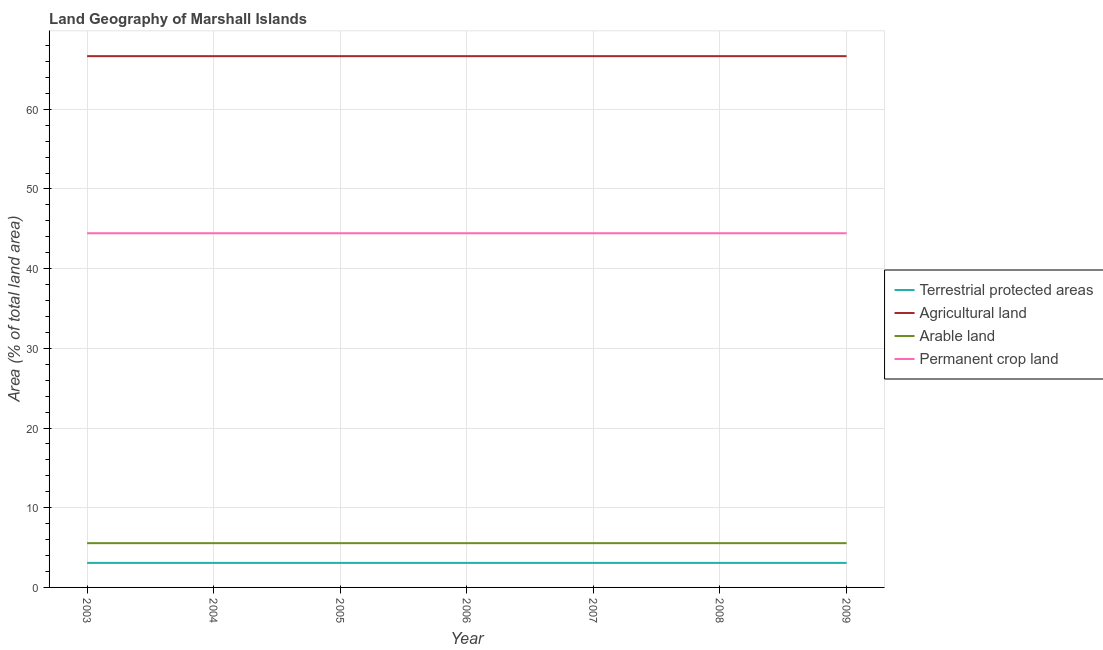How many different coloured lines are there?
Your answer should be compact. 4. Does the line corresponding to percentage of land under terrestrial protection intersect with the line corresponding to percentage of area under permanent crop land?
Your response must be concise. No. What is the percentage of area under agricultural land in 2008?
Offer a very short reply. 66.67. Across all years, what is the maximum percentage of area under arable land?
Offer a very short reply. 5.56. Across all years, what is the minimum percentage of land under terrestrial protection?
Provide a short and direct response. 3.08. In which year was the percentage of area under permanent crop land maximum?
Keep it short and to the point. 2003. In which year was the percentage of land under terrestrial protection minimum?
Give a very brief answer. 2003. What is the total percentage of area under arable land in the graph?
Your answer should be very brief. 38.89. What is the difference between the percentage of land under terrestrial protection in 2004 and that in 2008?
Offer a terse response. 0. What is the difference between the percentage of land under terrestrial protection in 2009 and the percentage of area under agricultural land in 2007?
Your answer should be very brief. -63.59. What is the average percentage of area under arable land per year?
Give a very brief answer. 5.56. In the year 2004, what is the difference between the percentage of area under agricultural land and percentage of land under terrestrial protection?
Provide a succinct answer. 63.59. Is it the case that in every year, the sum of the percentage of area under agricultural land and percentage of area under arable land is greater than the sum of percentage of area under permanent crop land and percentage of land under terrestrial protection?
Ensure brevity in your answer.  No. Does the percentage of area under permanent crop land monotonically increase over the years?
Give a very brief answer. No. How many years are there in the graph?
Your answer should be compact. 7. Where does the legend appear in the graph?
Make the answer very short. Center right. What is the title of the graph?
Provide a succinct answer. Land Geography of Marshall Islands. What is the label or title of the Y-axis?
Provide a short and direct response. Area (% of total land area). What is the Area (% of total land area) in Terrestrial protected areas in 2003?
Ensure brevity in your answer.  3.08. What is the Area (% of total land area) of Agricultural land in 2003?
Keep it short and to the point. 66.67. What is the Area (% of total land area) of Arable land in 2003?
Provide a succinct answer. 5.56. What is the Area (% of total land area) in Permanent crop land in 2003?
Your answer should be very brief. 44.44. What is the Area (% of total land area) in Terrestrial protected areas in 2004?
Your response must be concise. 3.08. What is the Area (% of total land area) of Agricultural land in 2004?
Ensure brevity in your answer.  66.67. What is the Area (% of total land area) of Arable land in 2004?
Your answer should be compact. 5.56. What is the Area (% of total land area) of Permanent crop land in 2004?
Offer a very short reply. 44.44. What is the Area (% of total land area) in Terrestrial protected areas in 2005?
Your response must be concise. 3.08. What is the Area (% of total land area) of Agricultural land in 2005?
Offer a terse response. 66.67. What is the Area (% of total land area) of Arable land in 2005?
Offer a very short reply. 5.56. What is the Area (% of total land area) of Permanent crop land in 2005?
Give a very brief answer. 44.44. What is the Area (% of total land area) of Terrestrial protected areas in 2006?
Offer a terse response. 3.08. What is the Area (% of total land area) of Agricultural land in 2006?
Your answer should be very brief. 66.67. What is the Area (% of total land area) of Arable land in 2006?
Your answer should be compact. 5.56. What is the Area (% of total land area) of Permanent crop land in 2006?
Provide a short and direct response. 44.44. What is the Area (% of total land area) in Terrestrial protected areas in 2007?
Make the answer very short. 3.08. What is the Area (% of total land area) in Agricultural land in 2007?
Provide a succinct answer. 66.67. What is the Area (% of total land area) in Arable land in 2007?
Offer a very short reply. 5.56. What is the Area (% of total land area) in Permanent crop land in 2007?
Offer a very short reply. 44.44. What is the Area (% of total land area) of Terrestrial protected areas in 2008?
Provide a short and direct response. 3.08. What is the Area (% of total land area) of Agricultural land in 2008?
Offer a very short reply. 66.67. What is the Area (% of total land area) of Arable land in 2008?
Keep it short and to the point. 5.56. What is the Area (% of total land area) in Permanent crop land in 2008?
Your response must be concise. 44.44. What is the Area (% of total land area) in Terrestrial protected areas in 2009?
Provide a succinct answer. 3.08. What is the Area (% of total land area) of Agricultural land in 2009?
Keep it short and to the point. 66.67. What is the Area (% of total land area) of Arable land in 2009?
Make the answer very short. 5.56. What is the Area (% of total land area) of Permanent crop land in 2009?
Your answer should be very brief. 44.44. Across all years, what is the maximum Area (% of total land area) of Terrestrial protected areas?
Ensure brevity in your answer.  3.08. Across all years, what is the maximum Area (% of total land area) of Agricultural land?
Give a very brief answer. 66.67. Across all years, what is the maximum Area (% of total land area) in Arable land?
Give a very brief answer. 5.56. Across all years, what is the maximum Area (% of total land area) of Permanent crop land?
Ensure brevity in your answer.  44.44. Across all years, what is the minimum Area (% of total land area) in Terrestrial protected areas?
Offer a terse response. 3.08. Across all years, what is the minimum Area (% of total land area) of Agricultural land?
Your answer should be very brief. 66.67. Across all years, what is the minimum Area (% of total land area) in Arable land?
Give a very brief answer. 5.56. Across all years, what is the minimum Area (% of total land area) in Permanent crop land?
Provide a short and direct response. 44.44. What is the total Area (% of total land area) in Terrestrial protected areas in the graph?
Offer a terse response. 21.55. What is the total Area (% of total land area) in Agricultural land in the graph?
Provide a short and direct response. 466.67. What is the total Area (% of total land area) of Arable land in the graph?
Make the answer very short. 38.89. What is the total Area (% of total land area) in Permanent crop land in the graph?
Offer a terse response. 311.11. What is the difference between the Area (% of total land area) in Terrestrial protected areas in 2003 and that in 2004?
Provide a succinct answer. 0. What is the difference between the Area (% of total land area) in Agricultural land in 2003 and that in 2004?
Your answer should be very brief. 0. What is the difference between the Area (% of total land area) of Arable land in 2003 and that in 2004?
Offer a terse response. 0. What is the difference between the Area (% of total land area) in Terrestrial protected areas in 2003 and that in 2006?
Make the answer very short. 0. What is the difference between the Area (% of total land area) in Terrestrial protected areas in 2003 and that in 2007?
Your response must be concise. 0. What is the difference between the Area (% of total land area) in Arable land in 2003 and that in 2007?
Your response must be concise. 0. What is the difference between the Area (% of total land area) in Permanent crop land in 2003 and that in 2007?
Provide a short and direct response. 0. What is the difference between the Area (% of total land area) in Agricultural land in 2003 and that in 2008?
Your answer should be very brief. 0. What is the difference between the Area (% of total land area) in Arable land in 2003 and that in 2008?
Offer a very short reply. 0. What is the difference between the Area (% of total land area) in Agricultural land in 2003 and that in 2009?
Provide a short and direct response. 0. What is the difference between the Area (% of total land area) in Arable land in 2003 and that in 2009?
Offer a very short reply. 0. What is the difference between the Area (% of total land area) in Terrestrial protected areas in 2004 and that in 2005?
Offer a very short reply. 0. What is the difference between the Area (% of total land area) of Arable land in 2004 and that in 2006?
Your answer should be compact. 0. What is the difference between the Area (% of total land area) in Arable land in 2004 and that in 2007?
Ensure brevity in your answer.  0. What is the difference between the Area (% of total land area) in Terrestrial protected areas in 2004 and that in 2009?
Make the answer very short. 0. What is the difference between the Area (% of total land area) of Agricultural land in 2004 and that in 2009?
Provide a short and direct response. 0. What is the difference between the Area (% of total land area) of Arable land in 2004 and that in 2009?
Your answer should be compact. 0. What is the difference between the Area (% of total land area) of Agricultural land in 2005 and that in 2006?
Keep it short and to the point. 0. What is the difference between the Area (% of total land area) in Permanent crop land in 2005 and that in 2006?
Provide a succinct answer. 0. What is the difference between the Area (% of total land area) in Terrestrial protected areas in 2005 and that in 2007?
Keep it short and to the point. 0. What is the difference between the Area (% of total land area) of Permanent crop land in 2005 and that in 2007?
Your answer should be very brief. 0. What is the difference between the Area (% of total land area) of Terrestrial protected areas in 2005 and that in 2008?
Keep it short and to the point. 0. What is the difference between the Area (% of total land area) in Agricultural land in 2005 and that in 2008?
Make the answer very short. 0. What is the difference between the Area (% of total land area) in Arable land in 2005 and that in 2008?
Your answer should be compact. 0. What is the difference between the Area (% of total land area) in Terrestrial protected areas in 2005 and that in 2009?
Give a very brief answer. 0. What is the difference between the Area (% of total land area) of Arable land in 2005 and that in 2009?
Your answer should be very brief. 0. What is the difference between the Area (% of total land area) in Terrestrial protected areas in 2006 and that in 2007?
Provide a short and direct response. 0. What is the difference between the Area (% of total land area) of Agricultural land in 2006 and that in 2007?
Your answer should be very brief. 0. What is the difference between the Area (% of total land area) in Arable land in 2006 and that in 2007?
Offer a very short reply. 0. What is the difference between the Area (% of total land area) in Permanent crop land in 2006 and that in 2008?
Provide a succinct answer. 0. What is the difference between the Area (% of total land area) in Arable land in 2006 and that in 2009?
Provide a short and direct response. 0. What is the difference between the Area (% of total land area) of Permanent crop land in 2006 and that in 2009?
Offer a very short reply. 0. What is the difference between the Area (% of total land area) in Terrestrial protected areas in 2007 and that in 2008?
Your answer should be compact. 0. What is the difference between the Area (% of total land area) in Agricultural land in 2007 and that in 2008?
Ensure brevity in your answer.  0. What is the difference between the Area (% of total land area) of Permanent crop land in 2007 and that in 2008?
Give a very brief answer. 0. What is the difference between the Area (% of total land area) in Arable land in 2007 and that in 2009?
Your answer should be compact. 0. What is the difference between the Area (% of total land area) in Permanent crop land in 2007 and that in 2009?
Your response must be concise. 0. What is the difference between the Area (% of total land area) of Agricultural land in 2008 and that in 2009?
Ensure brevity in your answer.  0. What is the difference between the Area (% of total land area) of Permanent crop land in 2008 and that in 2009?
Offer a very short reply. 0. What is the difference between the Area (% of total land area) in Terrestrial protected areas in 2003 and the Area (% of total land area) in Agricultural land in 2004?
Offer a very short reply. -63.59. What is the difference between the Area (% of total land area) in Terrestrial protected areas in 2003 and the Area (% of total land area) in Arable land in 2004?
Your answer should be compact. -2.48. What is the difference between the Area (% of total land area) of Terrestrial protected areas in 2003 and the Area (% of total land area) of Permanent crop land in 2004?
Make the answer very short. -41.37. What is the difference between the Area (% of total land area) of Agricultural land in 2003 and the Area (% of total land area) of Arable land in 2004?
Ensure brevity in your answer.  61.11. What is the difference between the Area (% of total land area) in Agricultural land in 2003 and the Area (% of total land area) in Permanent crop land in 2004?
Your answer should be very brief. 22.22. What is the difference between the Area (% of total land area) in Arable land in 2003 and the Area (% of total land area) in Permanent crop land in 2004?
Provide a succinct answer. -38.89. What is the difference between the Area (% of total land area) of Terrestrial protected areas in 2003 and the Area (% of total land area) of Agricultural land in 2005?
Provide a succinct answer. -63.59. What is the difference between the Area (% of total land area) in Terrestrial protected areas in 2003 and the Area (% of total land area) in Arable land in 2005?
Give a very brief answer. -2.48. What is the difference between the Area (% of total land area) in Terrestrial protected areas in 2003 and the Area (% of total land area) in Permanent crop land in 2005?
Keep it short and to the point. -41.37. What is the difference between the Area (% of total land area) of Agricultural land in 2003 and the Area (% of total land area) of Arable land in 2005?
Your answer should be very brief. 61.11. What is the difference between the Area (% of total land area) in Agricultural land in 2003 and the Area (% of total land area) in Permanent crop land in 2005?
Offer a very short reply. 22.22. What is the difference between the Area (% of total land area) of Arable land in 2003 and the Area (% of total land area) of Permanent crop land in 2005?
Your answer should be compact. -38.89. What is the difference between the Area (% of total land area) of Terrestrial protected areas in 2003 and the Area (% of total land area) of Agricultural land in 2006?
Your answer should be compact. -63.59. What is the difference between the Area (% of total land area) of Terrestrial protected areas in 2003 and the Area (% of total land area) of Arable land in 2006?
Ensure brevity in your answer.  -2.48. What is the difference between the Area (% of total land area) of Terrestrial protected areas in 2003 and the Area (% of total land area) of Permanent crop land in 2006?
Offer a terse response. -41.37. What is the difference between the Area (% of total land area) in Agricultural land in 2003 and the Area (% of total land area) in Arable land in 2006?
Give a very brief answer. 61.11. What is the difference between the Area (% of total land area) in Agricultural land in 2003 and the Area (% of total land area) in Permanent crop land in 2006?
Offer a terse response. 22.22. What is the difference between the Area (% of total land area) of Arable land in 2003 and the Area (% of total land area) of Permanent crop land in 2006?
Provide a succinct answer. -38.89. What is the difference between the Area (% of total land area) in Terrestrial protected areas in 2003 and the Area (% of total land area) in Agricultural land in 2007?
Make the answer very short. -63.59. What is the difference between the Area (% of total land area) of Terrestrial protected areas in 2003 and the Area (% of total land area) of Arable land in 2007?
Provide a short and direct response. -2.48. What is the difference between the Area (% of total land area) in Terrestrial protected areas in 2003 and the Area (% of total land area) in Permanent crop land in 2007?
Offer a terse response. -41.37. What is the difference between the Area (% of total land area) of Agricultural land in 2003 and the Area (% of total land area) of Arable land in 2007?
Provide a short and direct response. 61.11. What is the difference between the Area (% of total land area) of Agricultural land in 2003 and the Area (% of total land area) of Permanent crop land in 2007?
Provide a short and direct response. 22.22. What is the difference between the Area (% of total land area) in Arable land in 2003 and the Area (% of total land area) in Permanent crop land in 2007?
Keep it short and to the point. -38.89. What is the difference between the Area (% of total land area) of Terrestrial protected areas in 2003 and the Area (% of total land area) of Agricultural land in 2008?
Your answer should be compact. -63.59. What is the difference between the Area (% of total land area) of Terrestrial protected areas in 2003 and the Area (% of total land area) of Arable land in 2008?
Give a very brief answer. -2.48. What is the difference between the Area (% of total land area) of Terrestrial protected areas in 2003 and the Area (% of total land area) of Permanent crop land in 2008?
Offer a terse response. -41.37. What is the difference between the Area (% of total land area) of Agricultural land in 2003 and the Area (% of total land area) of Arable land in 2008?
Provide a succinct answer. 61.11. What is the difference between the Area (% of total land area) of Agricultural land in 2003 and the Area (% of total land area) of Permanent crop land in 2008?
Offer a very short reply. 22.22. What is the difference between the Area (% of total land area) in Arable land in 2003 and the Area (% of total land area) in Permanent crop land in 2008?
Your answer should be compact. -38.89. What is the difference between the Area (% of total land area) of Terrestrial protected areas in 2003 and the Area (% of total land area) of Agricultural land in 2009?
Offer a terse response. -63.59. What is the difference between the Area (% of total land area) of Terrestrial protected areas in 2003 and the Area (% of total land area) of Arable land in 2009?
Keep it short and to the point. -2.48. What is the difference between the Area (% of total land area) of Terrestrial protected areas in 2003 and the Area (% of total land area) of Permanent crop land in 2009?
Make the answer very short. -41.37. What is the difference between the Area (% of total land area) of Agricultural land in 2003 and the Area (% of total land area) of Arable land in 2009?
Ensure brevity in your answer.  61.11. What is the difference between the Area (% of total land area) in Agricultural land in 2003 and the Area (% of total land area) in Permanent crop land in 2009?
Offer a very short reply. 22.22. What is the difference between the Area (% of total land area) in Arable land in 2003 and the Area (% of total land area) in Permanent crop land in 2009?
Your response must be concise. -38.89. What is the difference between the Area (% of total land area) of Terrestrial protected areas in 2004 and the Area (% of total land area) of Agricultural land in 2005?
Offer a very short reply. -63.59. What is the difference between the Area (% of total land area) of Terrestrial protected areas in 2004 and the Area (% of total land area) of Arable land in 2005?
Your response must be concise. -2.48. What is the difference between the Area (% of total land area) of Terrestrial protected areas in 2004 and the Area (% of total land area) of Permanent crop land in 2005?
Your answer should be compact. -41.37. What is the difference between the Area (% of total land area) of Agricultural land in 2004 and the Area (% of total land area) of Arable land in 2005?
Keep it short and to the point. 61.11. What is the difference between the Area (% of total land area) in Agricultural land in 2004 and the Area (% of total land area) in Permanent crop land in 2005?
Provide a short and direct response. 22.22. What is the difference between the Area (% of total land area) in Arable land in 2004 and the Area (% of total land area) in Permanent crop land in 2005?
Provide a short and direct response. -38.89. What is the difference between the Area (% of total land area) in Terrestrial protected areas in 2004 and the Area (% of total land area) in Agricultural land in 2006?
Your answer should be very brief. -63.59. What is the difference between the Area (% of total land area) of Terrestrial protected areas in 2004 and the Area (% of total land area) of Arable land in 2006?
Your response must be concise. -2.48. What is the difference between the Area (% of total land area) of Terrestrial protected areas in 2004 and the Area (% of total land area) of Permanent crop land in 2006?
Your answer should be compact. -41.37. What is the difference between the Area (% of total land area) of Agricultural land in 2004 and the Area (% of total land area) of Arable land in 2006?
Your answer should be very brief. 61.11. What is the difference between the Area (% of total land area) of Agricultural land in 2004 and the Area (% of total land area) of Permanent crop land in 2006?
Offer a terse response. 22.22. What is the difference between the Area (% of total land area) of Arable land in 2004 and the Area (% of total land area) of Permanent crop land in 2006?
Make the answer very short. -38.89. What is the difference between the Area (% of total land area) in Terrestrial protected areas in 2004 and the Area (% of total land area) in Agricultural land in 2007?
Offer a very short reply. -63.59. What is the difference between the Area (% of total land area) of Terrestrial protected areas in 2004 and the Area (% of total land area) of Arable land in 2007?
Offer a very short reply. -2.48. What is the difference between the Area (% of total land area) of Terrestrial protected areas in 2004 and the Area (% of total land area) of Permanent crop land in 2007?
Offer a very short reply. -41.37. What is the difference between the Area (% of total land area) in Agricultural land in 2004 and the Area (% of total land area) in Arable land in 2007?
Provide a short and direct response. 61.11. What is the difference between the Area (% of total land area) in Agricultural land in 2004 and the Area (% of total land area) in Permanent crop land in 2007?
Give a very brief answer. 22.22. What is the difference between the Area (% of total land area) of Arable land in 2004 and the Area (% of total land area) of Permanent crop land in 2007?
Offer a terse response. -38.89. What is the difference between the Area (% of total land area) in Terrestrial protected areas in 2004 and the Area (% of total land area) in Agricultural land in 2008?
Keep it short and to the point. -63.59. What is the difference between the Area (% of total land area) in Terrestrial protected areas in 2004 and the Area (% of total land area) in Arable land in 2008?
Keep it short and to the point. -2.48. What is the difference between the Area (% of total land area) of Terrestrial protected areas in 2004 and the Area (% of total land area) of Permanent crop land in 2008?
Your answer should be very brief. -41.37. What is the difference between the Area (% of total land area) of Agricultural land in 2004 and the Area (% of total land area) of Arable land in 2008?
Your answer should be very brief. 61.11. What is the difference between the Area (% of total land area) in Agricultural land in 2004 and the Area (% of total land area) in Permanent crop land in 2008?
Offer a terse response. 22.22. What is the difference between the Area (% of total land area) of Arable land in 2004 and the Area (% of total land area) of Permanent crop land in 2008?
Give a very brief answer. -38.89. What is the difference between the Area (% of total land area) in Terrestrial protected areas in 2004 and the Area (% of total land area) in Agricultural land in 2009?
Provide a succinct answer. -63.59. What is the difference between the Area (% of total land area) of Terrestrial protected areas in 2004 and the Area (% of total land area) of Arable land in 2009?
Your response must be concise. -2.48. What is the difference between the Area (% of total land area) of Terrestrial protected areas in 2004 and the Area (% of total land area) of Permanent crop land in 2009?
Your answer should be compact. -41.37. What is the difference between the Area (% of total land area) of Agricultural land in 2004 and the Area (% of total land area) of Arable land in 2009?
Your answer should be compact. 61.11. What is the difference between the Area (% of total land area) in Agricultural land in 2004 and the Area (% of total land area) in Permanent crop land in 2009?
Your answer should be very brief. 22.22. What is the difference between the Area (% of total land area) in Arable land in 2004 and the Area (% of total land area) in Permanent crop land in 2009?
Keep it short and to the point. -38.89. What is the difference between the Area (% of total land area) in Terrestrial protected areas in 2005 and the Area (% of total land area) in Agricultural land in 2006?
Your answer should be compact. -63.59. What is the difference between the Area (% of total land area) of Terrestrial protected areas in 2005 and the Area (% of total land area) of Arable land in 2006?
Your response must be concise. -2.48. What is the difference between the Area (% of total land area) in Terrestrial protected areas in 2005 and the Area (% of total land area) in Permanent crop land in 2006?
Make the answer very short. -41.37. What is the difference between the Area (% of total land area) of Agricultural land in 2005 and the Area (% of total land area) of Arable land in 2006?
Give a very brief answer. 61.11. What is the difference between the Area (% of total land area) of Agricultural land in 2005 and the Area (% of total land area) of Permanent crop land in 2006?
Offer a terse response. 22.22. What is the difference between the Area (% of total land area) of Arable land in 2005 and the Area (% of total land area) of Permanent crop land in 2006?
Offer a very short reply. -38.89. What is the difference between the Area (% of total land area) of Terrestrial protected areas in 2005 and the Area (% of total land area) of Agricultural land in 2007?
Provide a short and direct response. -63.59. What is the difference between the Area (% of total land area) of Terrestrial protected areas in 2005 and the Area (% of total land area) of Arable land in 2007?
Your answer should be very brief. -2.48. What is the difference between the Area (% of total land area) of Terrestrial protected areas in 2005 and the Area (% of total land area) of Permanent crop land in 2007?
Provide a succinct answer. -41.37. What is the difference between the Area (% of total land area) in Agricultural land in 2005 and the Area (% of total land area) in Arable land in 2007?
Ensure brevity in your answer.  61.11. What is the difference between the Area (% of total land area) in Agricultural land in 2005 and the Area (% of total land area) in Permanent crop land in 2007?
Ensure brevity in your answer.  22.22. What is the difference between the Area (% of total land area) in Arable land in 2005 and the Area (% of total land area) in Permanent crop land in 2007?
Keep it short and to the point. -38.89. What is the difference between the Area (% of total land area) in Terrestrial protected areas in 2005 and the Area (% of total land area) in Agricultural land in 2008?
Keep it short and to the point. -63.59. What is the difference between the Area (% of total land area) in Terrestrial protected areas in 2005 and the Area (% of total land area) in Arable land in 2008?
Provide a succinct answer. -2.48. What is the difference between the Area (% of total land area) in Terrestrial protected areas in 2005 and the Area (% of total land area) in Permanent crop land in 2008?
Provide a succinct answer. -41.37. What is the difference between the Area (% of total land area) of Agricultural land in 2005 and the Area (% of total land area) of Arable land in 2008?
Your answer should be compact. 61.11. What is the difference between the Area (% of total land area) of Agricultural land in 2005 and the Area (% of total land area) of Permanent crop land in 2008?
Your response must be concise. 22.22. What is the difference between the Area (% of total land area) of Arable land in 2005 and the Area (% of total land area) of Permanent crop land in 2008?
Give a very brief answer. -38.89. What is the difference between the Area (% of total land area) of Terrestrial protected areas in 2005 and the Area (% of total land area) of Agricultural land in 2009?
Give a very brief answer. -63.59. What is the difference between the Area (% of total land area) of Terrestrial protected areas in 2005 and the Area (% of total land area) of Arable land in 2009?
Your response must be concise. -2.48. What is the difference between the Area (% of total land area) in Terrestrial protected areas in 2005 and the Area (% of total land area) in Permanent crop land in 2009?
Keep it short and to the point. -41.37. What is the difference between the Area (% of total land area) of Agricultural land in 2005 and the Area (% of total land area) of Arable land in 2009?
Offer a terse response. 61.11. What is the difference between the Area (% of total land area) of Agricultural land in 2005 and the Area (% of total land area) of Permanent crop land in 2009?
Keep it short and to the point. 22.22. What is the difference between the Area (% of total land area) of Arable land in 2005 and the Area (% of total land area) of Permanent crop land in 2009?
Provide a succinct answer. -38.89. What is the difference between the Area (% of total land area) of Terrestrial protected areas in 2006 and the Area (% of total land area) of Agricultural land in 2007?
Provide a succinct answer. -63.59. What is the difference between the Area (% of total land area) of Terrestrial protected areas in 2006 and the Area (% of total land area) of Arable land in 2007?
Provide a short and direct response. -2.48. What is the difference between the Area (% of total land area) of Terrestrial protected areas in 2006 and the Area (% of total land area) of Permanent crop land in 2007?
Make the answer very short. -41.37. What is the difference between the Area (% of total land area) in Agricultural land in 2006 and the Area (% of total land area) in Arable land in 2007?
Offer a terse response. 61.11. What is the difference between the Area (% of total land area) in Agricultural land in 2006 and the Area (% of total land area) in Permanent crop land in 2007?
Ensure brevity in your answer.  22.22. What is the difference between the Area (% of total land area) in Arable land in 2006 and the Area (% of total land area) in Permanent crop land in 2007?
Your answer should be very brief. -38.89. What is the difference between the Area (% of total land area) in Terrestrial protected areas in 2006 and the Area (% of total land area) in Agricultural land in 2008?
Ensure brevity in your answer.  -63.59. What is the difference between the Area (% of total land area) of Terrestrial protected areas in 2006 and the Area (% of total land area) of Arable land in 2008?
Offer a very short reply. -2.48. What is the difference between the Area (% of total land area) of Terrestrial protected areas in 2006 and the Area (% of total land area) of Permanent crop land in 2008?
Provide a succinct answer. -41.37. What is the difference between the Area (% of total land area) of Agricultural land in 2006 and the Area (% of total land area) of Arable land in 2008?
Offer a very short reply. 61.11. What is the difference between the Area (% of total land area) of Agricultural land in 2006 and the Area (% of total land area) of Permanent crop land in 2008?
Keep it short and to the point. 22.22. What is the difference between the Area (% of total land area) of Arable land in 2006 and the Area (% of total land area) of Permanent crop land in 2008?
Your response must be concise. -38.89. What is the difference between the Area (% of total land area) in Terrestrial protected areas in 2006 and the Area (% of total land area) in Agricultural land in 2009?
Provide a succinct answer. -63.59. What is the difference between the Area (% of total land area) of Terrestrial protected areas in 2006 and the Area (% of total land area) of Arable land in 2009?
Provide a succinct answer. -2.48. What is the difference between the Area (% of total land area) in Terrestrial protected areas in 2006 and the Area (% of total land area) in Permanent crop land in 2009?
Provide a succinct answer. -41.37. What is the difference between the Area (% of total land area) in Agricultural land in 2006 and the Area (% of total land area) in Arable land in 2009?
Make the answer very short. 61.11. What is the difference between the Area (% of total land area) of Agricultural land in 2006 and the Area (% of total land area) of Permanent crop land in 2009?
Give a very brief answer. 22.22. What is the difference between the Area (% of total land area) in Arable land in 2006 and the Area (% of total land area) in Permanent crop land in 2009?
Offer a very short reply. -38.89. What is the difference between the Area (% of total land area) of Terrestrial protected areas in 2007 and the Area (% of total land area) of Agricultural land in 2008?
Provide a short and direct response. -63.59. What is the difference between the Area (% of total land area) in Terrestrial protected areas in 2007 and the Area (% of total land area) in Arable land in 2008?
Offer a very short reply. -2.48. What is the difference between the Area (% of total land area) in Terrestrial protected areas in 2007 and the Area (% of total land area) in Permanent crop land in 2008?
Give a very brief answer. -41.37. What is the difference between the Area (% of total land area) of Agricultural land in 2007 and the Area (% of total land area) of Arable land in 2008?
Keep it short and to the point. 61.11. What is the difference between the Area (% of total land area) of Agricultural land in 2007 and the Area (% of total land area) of Permanent crop land in 2008?
Keep it short and to the point. 22.22. What is the difference between the Area (% of total land area) in Arable land in 2007 and the Area (% of total land area) in Permanent crop land in 2008?
Offer a terse response. -38.89. What is the difference between the Area (% of total land area) of Terrestrial protected areas in 2007 and the Area (% of total land area) of Agricultural land in 2009?
Provide a succinct answer. -63.59. What is the difference between the Area (% of total land area) of Terrestrial protected areas in 2007 and the Area (% of total land area) of Arable land in 2009?
Make the answer very short. -2.48. What is the difference between the Area (% of total land area) in Terrestrial protected areas in 2007 and the Area (% of total land area) in Permanent crop land in 2009?
Ensure brevity in your answer.  -41.37. What is the difference between the Area (% of total land area) of Agricultural land in 2007 and the Area (% of total land area) of Arable land in 2009?
Give a very brief answer. 61.11. What is the difference between the Area (% of total land area) in Agricultural land in 2007 and the Area (% of total land area) in Permanent crop land in 2009?
Your answer should be compact. 22.22. What is the difference between the Area (% of total land area) of Arable land in 2007 and the Area (% of total land area) of Permanent crop land in 2009?
Offer a very short reply. -38.89. What is the difference between the Area (% of total land area) in Terrestrial protected areas in 2008 and the Area (% of total land area) in Agricultural land in 2009?
Your answer should be compact. -63.59. What is the difference between the Area (% of total land area) of Terrestrial protected areas in 2008 and the Area (% of total land area) of Arable land in 2009?
Give a very brief answer. -2.48. What is the difference between the Area (% of total land area) in Terrestrial protected areas in 2008 and the Area (% of total land area) in Permanent crop land in 2009?
Ensure brevity in your answer.  -41.37. What is the difference between the Area (% of total land area) of Agricultural land in 2008 and the Area (% of total land area) of Arable land in 2009?
Offer a terse response. 61.11. What is the difference between the Area (% of total land area) of Agricultural land in 2008 and the Area (% of total land area) of Permanent crop land in 2009?
Give a very brief answer. 22.22. What is the difference between the Area (% of total land area) in Arable land in 2008 and the Area (% of total land area) in Permanent crop land in 2009?
Your response must be concise. -38.89. What is the average Area (% of total land area) of Terrestrial protected areas per year?
Your answer should be very brief. 3.08. What is the average Area (% of total land area) in Agricultural land per year?
Keep it short and to the point. 66.67. What is the average Area (% of total land area) of Arable land per year?
Keep it short and to the point. 5.56. What is the average Area (% of total land area) of Permanent crop land per year?
Give a very brief answer. 44.44. In the year 2003, what is the difference between the Area (% of total land area) in Terrestrial protected areas and Area (% of total land area) in Agricultural land?
Offer a very short reply. -63.59. In the year 2003, what is the difference between the Area (% of total land area) of Terrestrial protected areas and Area (% of total land area) of Arable land?
Offer a terse response. -2.48. In the year 2003, what is the difference between the Area (% of total land area) of Terrestrial protected areas and Area (% of total land area) of Permanent crop land?
Offer a very short reply. -41.37. In the year 2003, what is the difference between the Area (% of total land area) in Agricultural land and Area (% of total land area) in Arable land?
Provide a short and direct response. 61.11. In the year 2003, what is the difference between the Area (% of total land area) in Agricultural land and Area (% of total land area) in Permanent crop land?
Offer a terse response. 22.22. In the year 2003, what is the difference between the Area (% of total land area) of Arable land and Area (% of total land area) of Permanent crop land?
Provide a succinct answer. -38.89. In the year 2004, what is the difference between the Area (% of total land area) in Terrestrial protected areas and Area (% of total land area) in Agricultural land?
Provide a succinct answer. -63.59. In the year 2004, what is the difference between the Area (% of total land area) of Terrestrial protected areas and Area (% of total land area) of Arable land?
Your response must be concise. -2.48. In the year 2004, what is the difference between the Area (% of total land area) of Terrestrial protected areas and Area (% of total land area) of Permanent crop land?
Provide a short and direct response. -41.37. In the year 2004, what is the difference between the Area (% of total land area) in Agricultural land and Area (% of total land area) in Arable land?
Ensure brevity in your answer.  61.11. In the year 2004, what is the difference between the Area (% of total land area) of Agricultural land and Area (% of total land area) of Permanent crop land?
Offer a very short reply. 22.22. In the year 2004, what is the difference between the Area (% of total land area) in Arable land and Area (% of total land area) in Permanent crop land?
Offer a terse response. -38.89. In the year 2005, what is the difference between the Area (% of total land area) in Terrestrial protected areas and Area (% of total land area) in Agricultural land?
Offer a very short reply. -63.59. In the year 2005, what is the difference between the Area (% of total land area) of Terrestrial protected areas and Area (% of total land area) of Arable land?
Give a very brief answer. -2.48. In the year 2005, what is the difference between the Area (% of total land area) of Terrestrial protected areas and Area (% of total land area) of Permanent crop land?
Offer a terse response. -41.37. In the year 2005, what is the difference between the Area (% of total land area) in Agricultural land and Area (% of total land area) in Arable land?
Offer a very short reply. 61.11. In the year 2005, what is the difference between the Area (% of total land area) of Agricultural land and Area (% of total land area) of Permanent crop land?
Your answer should be very brief. 22.22. In the year 2005, what is the difference between the Area (% of total land area) in Arable land and Area (% of total land area) in Permanent crop land?
Your answer should be very brief. -38.89. In the year 2006, what is the difference between the Area (% of total land area) of Terrestrial protected areas and Area (% of total land area) of Agricultural land?
Your response must be concise. -63.59. In the year 2006, what is the difference between the Area (% of total land area) in Terrestrial protected areas and Area (% of total land area) in Arable land?
Your answer should be compact. -2.48. In the year 2006, what is the difference between the Area (% of total land area) in Terrestrial protected areas and Area (% of total land area) in Permanent crop land?
Provide a short and direct response. -41.37. In the year 2006, what is the difference between the Area (% of total land area) in Agricultural land and Area (% of total land area) in Arable land?
Provide a short and direct response. 61.11. In the year 2006, what is the difference between the Area (% of total land area) of Agricultural land and Area (% of total land area) of Permanent crop land?
Your answer should be compact. 22.22. In the year 2006, what is the difference between the Area (% of total land area) of Arable land and Area (% of total land area) of Permanent crop land?
Your answer should be very brief. -38.89. In the year 2007, what is the difference between the Area (% of total land area) of Terrestrial protected areas and Area (% of total land area) of Agricultural land?
Make the answer very short. -63.59. In the year 2007, what is the difference between the Area (% of total land area) in Terrestrial protected areas and Area (% of total land area) in Arable land?
Your response must be concise. -2.48. In the year 2007, what is the difference between the Area (% of total land area) of Terrestrial protected areas and Area (% of total land area) of Permanent crop land?
Offer a very short reply. -41.37. In the year 2007, what is the difference between the Area (% of total land area) in Agricultural land and Area (% of total land area) in Arable land?
Your answer should be very brief. 61.11. In the year 2007, what is the difference between the Area (% of total land area) of Agricultural land and Area (% of total land area) of Permanent crop land?
Provide a short and direct response. 22.22. In the year 2007, what is the difference between the Area (% of total land area) in Arable land and Area (% of total land area) in Permanent crop land?
Provide a short and direct response. -38.89. In the year 2008, what is the difference between the Area (% of total land area) in Terrestrial protected areas and Area (% of total land area) in Agricultural land?
Your answer should be compact. -63.59. In the year 2008, what is the difference between the Area (% of total land area) in Terrestrial protected areas and Area (% of total land area) in Arable land?
Make the answer very short. -2.48. In the year 2008, what is the difference between the Area (% of total land area) in Terrestrial protected areas and Area (% of total land area) in Permanent crop land?
Offer a very short reply. -41.37. In the year 2008, what is the difference between the Area (% of total land area) of Agricultural land and Area (% of total land area) of Arable land?
Offer a terse response. 61.11. In the year 2008, what is the difference between the Area (% of total land area) of Agricultural land and Area (% of total land area) of Permanent crop land?
Keep it short and to the point. 22.22. In the year 2008, what is the difference between the Area (% of total land area) in Arable land and Area (% of total land area) in Permanent crop land?
Offer a very short reply. -38.89. In the year 2009, what is the difference between the Area (% of total land area) of Terrestrial protected areas and Area (% of total land area) of Agricultural land?
Give a very brief answer. -63.59. In the year 2009, what is the difference between the Area (% of total land area) of Terrestrial protected areas and Area (% of total land area) of Arable land?
Your response must be concise. -2.48. In the year 2009, what is the difference between the Area (% of total land area) of Terrestrial protected areas and Area (% of total land area) of Permanent crop land?
Your answer should be very brief. -41.37. In the year 2009, what is the difference between the Area (% of total land area) of Agricultural land and Area (% of total land area) of Arable land?
Your response must be concise. 61.11. In the year 2009, what is the difference between the Area (% of total land area) in Agricultural land and Area (% of total land area) in Permanent crop land?
Offer a terse response. 22.22. In the year 2009, what is the difference between the Area (% of total land area) in Arable land and Area (% of total land area) in Permanent crop land?
Ensure brevity in your answer.  -38.89. What is the ratio of the Area (% of total land area) of Agricultural land in 2003 to that in 2004?
Provide a short and direct response. 1. What is the ratio of the Area (% of total land area) in Arable land in 2003 to that in 2004?
Provide a succinct answer. 1. What is the ratio of the Area (% of total land area) in Permanent crop land in 2003 to that in 2004?
Provide a short and direct response. 1. What is the ratio of the Area (% of total land area) in Terrestrial protected areas in 2003 to that in 2006?
Provide a succinct answer. 1. What is the ratio of the Area (% of total land area) of Agricultural land in 2003 to that in 2006?
Ensure brevity in your answer.  1. What is the ratio of the Area (% of total land area) of Arable land in 2003 to that in 2006?
Your answer should be very brief. 1. What is the ratio of the Area (% of total land area) in Permanent crop land in 2003 to that in 2006?
Offer a very short reply. 1. What is the ratio of the Area (% of total land area) of Agricultural land in 2003 to that in 2007?
Ensure brevity in your answer.  1. What is the ratio of the Area (% of total land area) in Permanent crop land in 2003 to that in 2007?
Provide a short and direct response. 1. What is the ratio of the Area (% of total land area) of Arable land in 2003 to that in 2008?
Your response must be concise. 1. What is the ratio of the Area (% of total land area) in Agricultural land in 2003 to that in 2009?
Provide a short and direct response. 1. What is the ratio of the Area (% of total land area) of Arable land in 2003 to that in 2009?
Provide a succinct answer. 1. What is the ratio of the Area (% of total land area) in Permanent crop land in 2003 to that in 2009?
Give a very brief answer. 1. What is the ratio of the Area (% of total land area) in Agricultural land in 2004 to that in 2005?
Provide a short and direct response. 1. What is the ratio of the Area (% of total land area) of Arable land in 2004 to that in 2005?
Offer a very short reply. 1. What is the ratio of the Area (% of total land area) in Terrestrial protected areas in 2004 to that in 2006?
Your answer should be compact. 1. What is the ratio of the Area (% of total land area) of Agricultural land in 2004 to that in 2006?
Your answer should be compact. 1. What is the ratio of the Area (% of total land area) of Arable land in 2004 to that in 2006?
Your response must be concise. 1. What is the ratio of the Area (% of total land area) in Terrestrial protected areas in 2004 to that in 2007?
Give a very brief answer. 1. What is the ratio of the Area (% of total land area) in Agricultural land in 2004 to that in 2007?
Give a very brief answer. 1. What is the ratio of the Area (% of total land area) of Agricultural land in 2004 to that in 2008?
Provide a short and direct response. 1. What is the ratio of the Area (% of total land area) in Arable land in 2004 to that in 2008?
Your answer should be very brief. 1. What is the ratio of the Area (% of total land area) in Permanent crop land in 2004 to that in 2008?
Keep it short and to the point. 1. What is the ratio of the Area (% of total land area) of Terrestrial protected areas in 2004 to that in 2009?
Ensure brevity in your answer.  1. What is the ratio of the Area (% of total land area) of Agricultural land in 2004 to that in 2009?
Provide a short and direct response. 1. What is the ratio of the Area (% of total land area) in Arable land in 2004 to that in 2009?
Your answer should be compact. 1. What is the ratio of the Area (% of total land area) of Terrestrial protected areas in 2005 to that in 2006?
Make the answer very short. 1. What is the ratio of the Area (% of total land area) in Arable land in 2005 to that in 2006?
Your response must be concise. 1. What is the ratio of the Area (% of total land area) of Agricultural land in 2005 to that in 2007?
Provide a short and direct response. 1. What is the ratio of the Area (% of total land area) of Arable land in 2005 to that in 2007?
Offer a terse response. 1. What is the ratio of the Area (% of total land area) in Permanent crop land in 2005 to that in 2007?
Make the answer very short. 1. What is the ratio of the Area (% of total land area) of Terrestrial protected areas in 2005 to that in 2008?
Provide a short and direct response. 1. What is the ratio of the Area (% of total land area) of Agricultural land in 2005 to that in 2008?
Your response must be concise. 1. What is the ratio of the Area (% of total land area) of Arable land in 2005 to that in 2008?
Your answer should be compact. 1. What is the ratio of the Area (% of total land area) of Permanent crop land in 2005 to that in 2008?
Ensure brevity in your answer.  1. What is the ratio of the Area (% of total land area) in Terrestrial protected areas in 2005 to that in 2009?
Keep it short and to the point. 1. What is the ratio of the Area (% of total land area) of Agricultural land in 2005 to that in 2009?
Keep it short and to the point. 1. What is the ratio of the Area (% of total land area) in Arable land in 2005 to that in 2009?
Keep it short and to the point. 1. What is the ratio of the Area (% of total land area) in Permanent crop land in 2005 to that in 2009?
Make the answer very short. 1. What is the ratio of the Area (% of total land area) of Terrestrial protected areas in 2006 to that in 2007?
Your answer should be compact. 1. What is the ratio of the Area (% of total land area) in Permanent crop land in 2006 to that in 2007?
Keep it short and to the point. 1. What is the ratio of the Area (% of total land area) in Agricultural land in 2006 to that in 2008?
Your response must be concise. 1. What is the ratio of the Area (% of total land area) in Arable land in 2006 to that in 2008?
Ensure brevity in your answer.  1. What is the ratio of the Area (% of total land area) of Terrestrial protected areas in 2006 to that in 2009?
Offer a very short reply. 1. What is the ratio of the Area (% of total land area) in Arable land in 2006 to that in 2009?
Your answer should be compact. 1. What is the ratio of the Area (% of total land area) of Permanent crop land in 2006 to that in 2009?
Make the answer very short. 1. What is the ratio of the Area (% of total land area) of Arable land in 2007 to that in 2008?
Provide a succinct answer. 1. What is the ratio of the Area (% of total land area) in Permanent crop land in 2007 to that in 2008?
Your answer should be compact. 1. What is the ratio of the Area (% of total land area) in Terrestrial protected areas in 2007 to that in 2009?
Offer a terse response. 1. What is the ratio of the Area (% of total land area) in Arable land in 2007 to that in 2009?
Provide a succinct answer. 1. What is the ratio of the Area (% of total land area) of Permanent crop land in 2007 to that in 2009?
Provide a succinct answer. 1. What is the ratio of the Area (% of total land area) of Agricultural land in 2008 to that in 2009?
Provide a succinct answer. 1. What is the difference between the highest and the second highest Area (% of total land area) of Terrestrial protected areas?
Offer a terse response. 0. What is the difference between the highest and the second highest Area (% of total land area) of Agricultural land?
Provide a short and direct response. 0. What is the difference between the highest and the lowest Area (% of total land area) of Agricultural land?
Give a very brief answer. 0. What is the difference between the highest and the lowest Area (% of total land area) of Arable land?
Ensure brevity in your answer.  0. What is the difference between the highest and the lowest Area (% of total land area) of Permanent crop land?
Your answer should be compact. 0. 